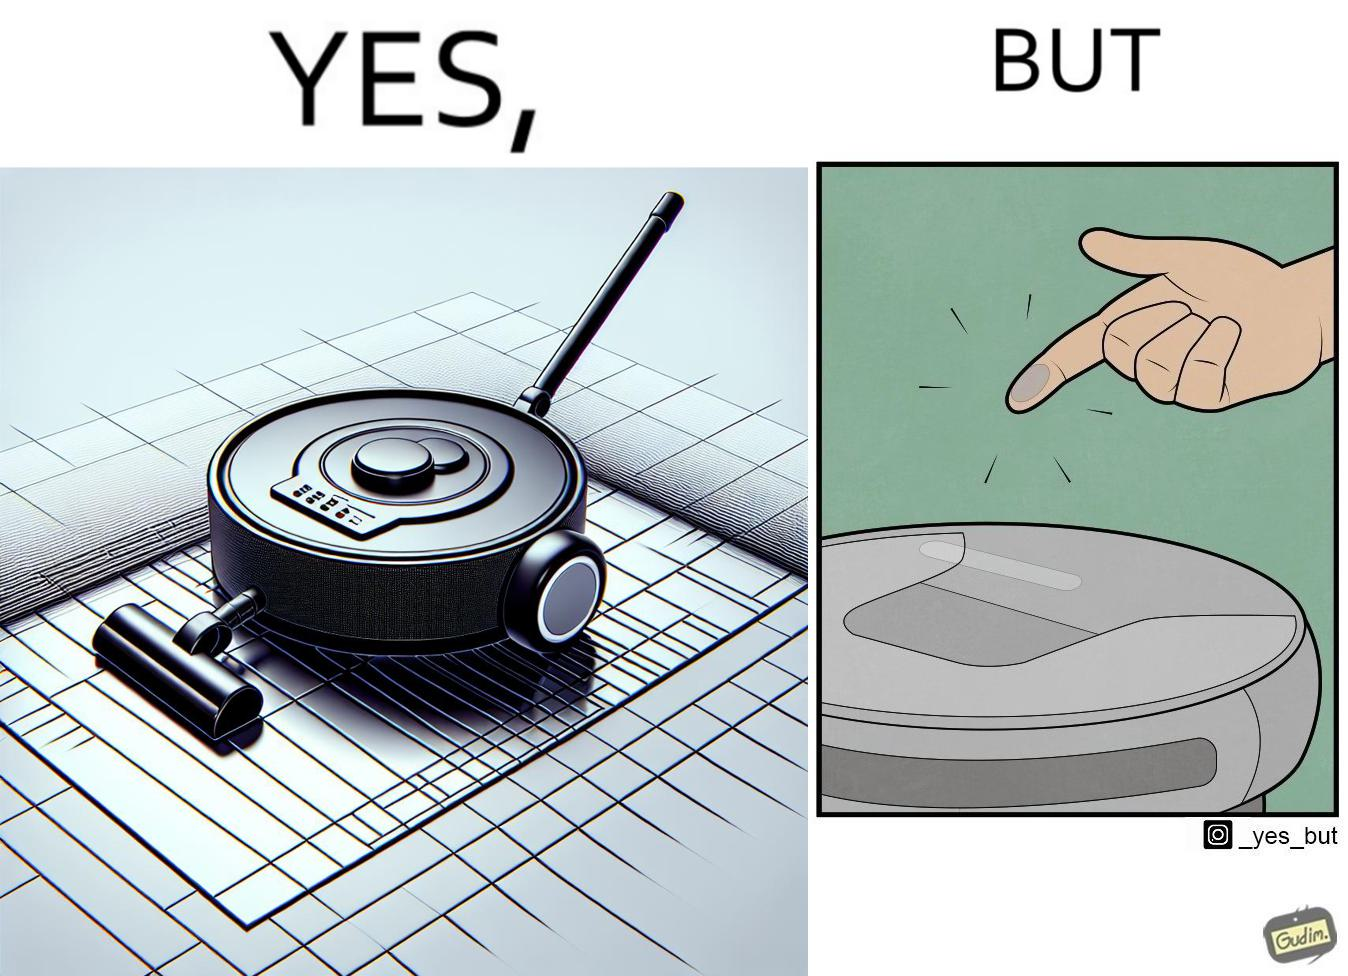What is shown in this image? This is funny, because the machine while doing its job cleans everything but ends up being dirty itself. 